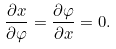Convert formula to latex. <formula><loc_0><loc_0><loc_500><loc_500>\frac { \partial x } { \partial \varphi } = \frac { \partial \varphi } { \partial x } = 0 .</formula> 